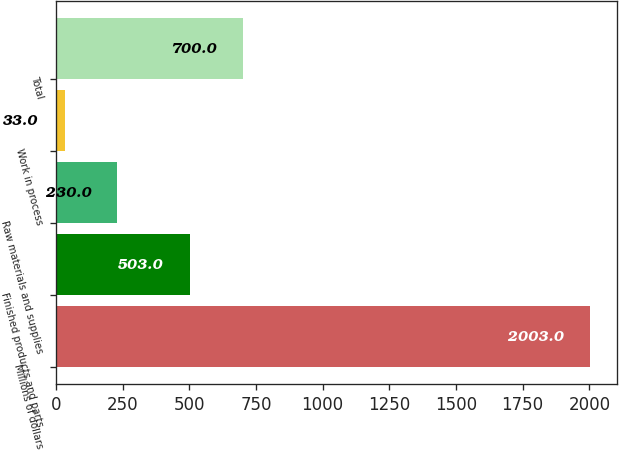<chart> <loc_0><loc_0><loc_500><loc_500><bar_chart><fcel>Millions of dollars<fcel>Finished products and parts<fcel>Raw materials and supplies<fcel>Work in process<fcel>Total<nl><fcel>2003<fcel>503<fcel>230<fcel>33<fcel>700<nl></chart> 